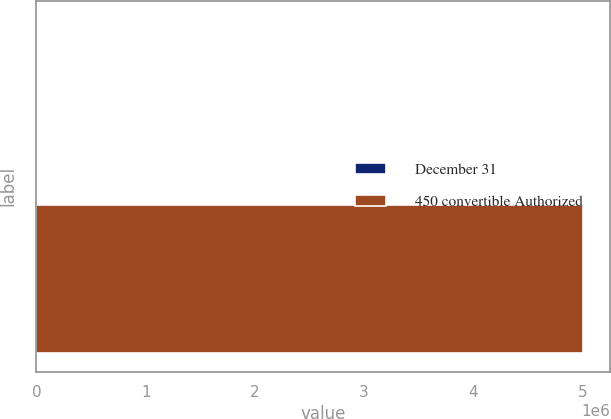<chart> <loc_0><loc_0><loc_500><loc_500><bar_chart><fcel>December 31<fcel>450 convertible Authorized<nl><fcel>2006<fcel>5e+06<nl></chart> 